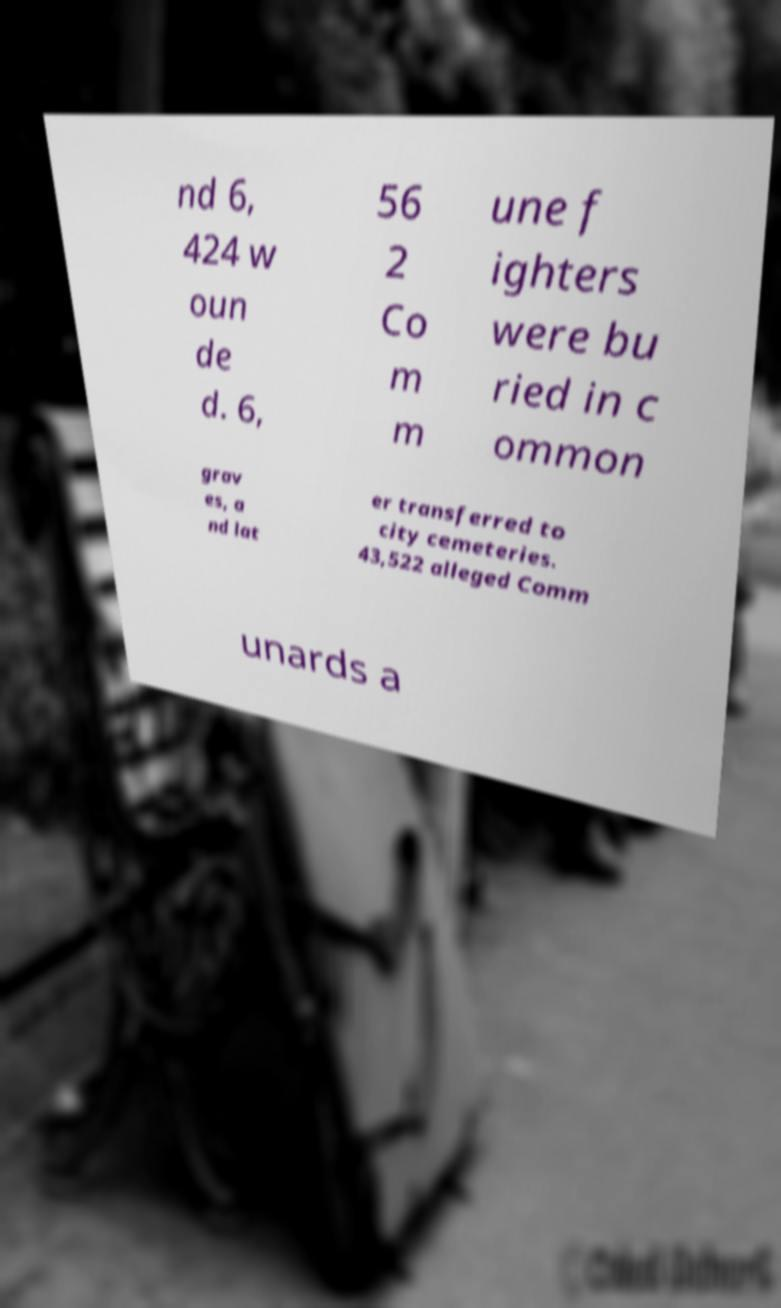Could you assist in decoding the text presented in this image and type it out clearly? nd 6, 424 w oun de d. 6, 56 2 Co m m une f ighters were bu ried in c ommon grav es, a nd lat er transferred to city cemeteries. 43,522 alleged Comm unards a 